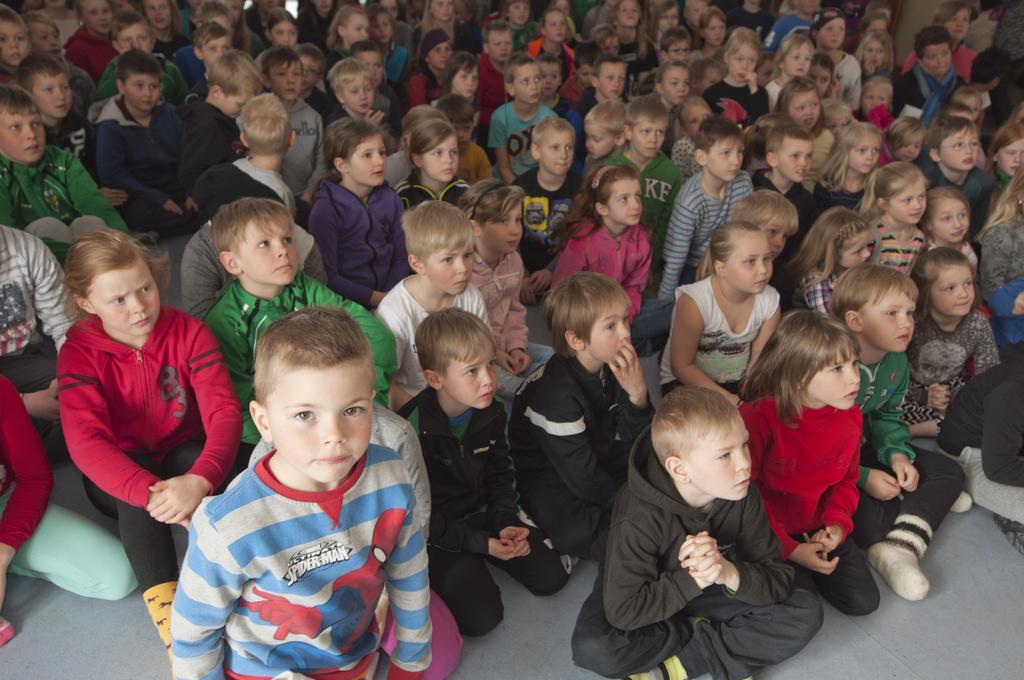How many people are in the image? There are many children in the image. What are the children doing in the image? The children are sitting on the floor. What type of pig can be seen comforting the children in the image? There is no pig present in the image, and the children are not being comforted by any animals. 